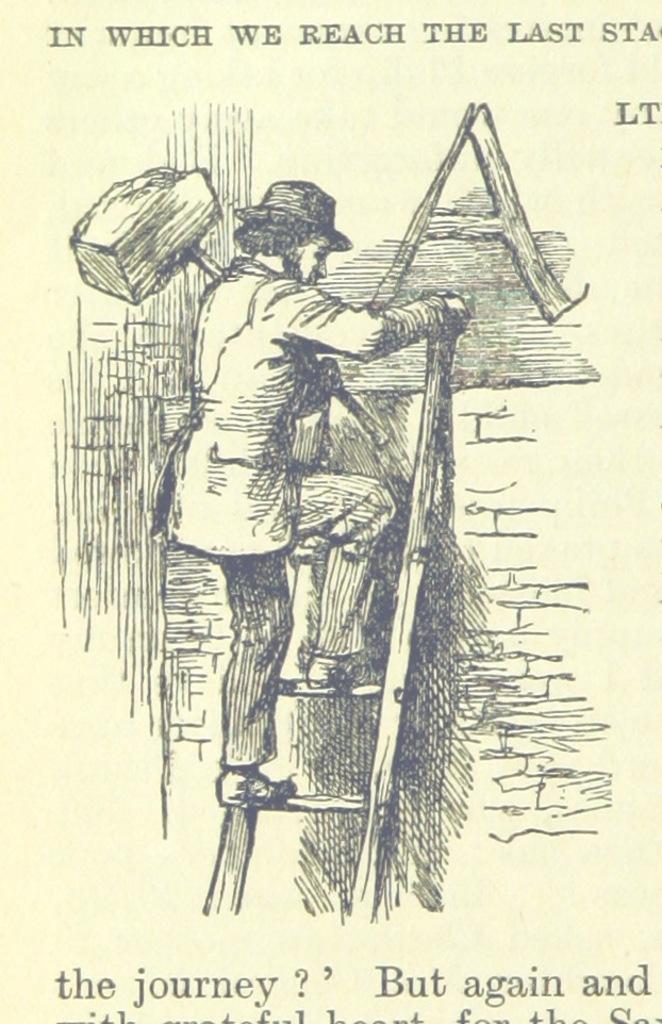Please provide a concise description of this image. In this image, I can see a paper with words and a picture of a person holding an object and climbing the ladder. 